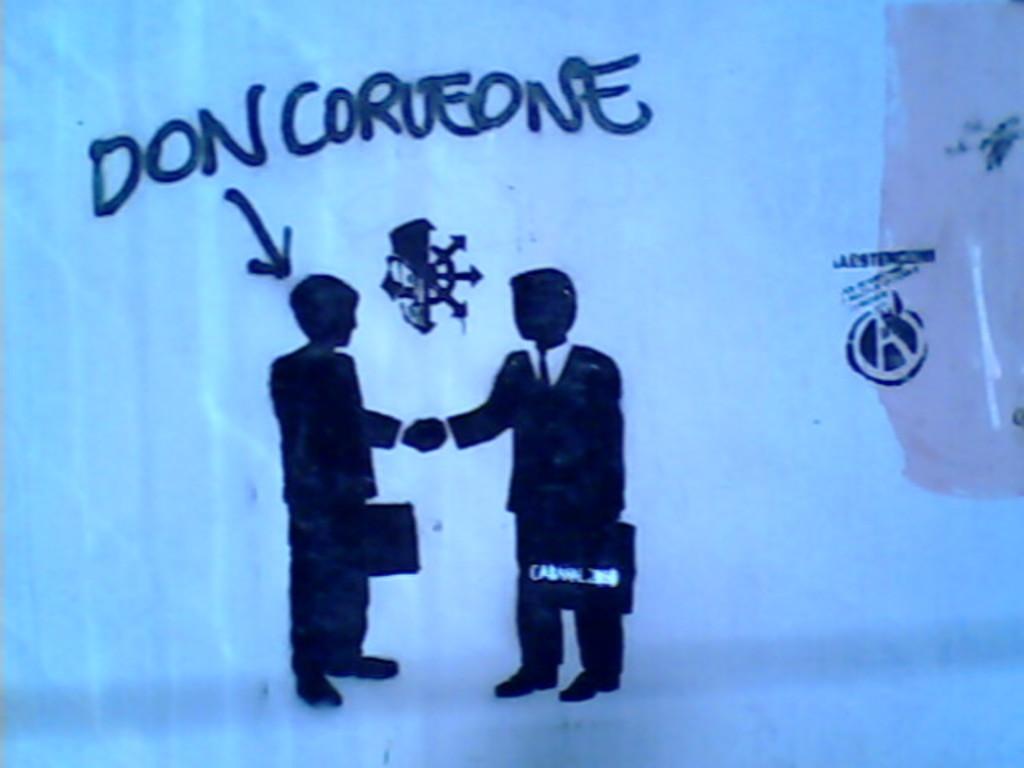What letter is written to the right?
Give a very brief answer. A. 